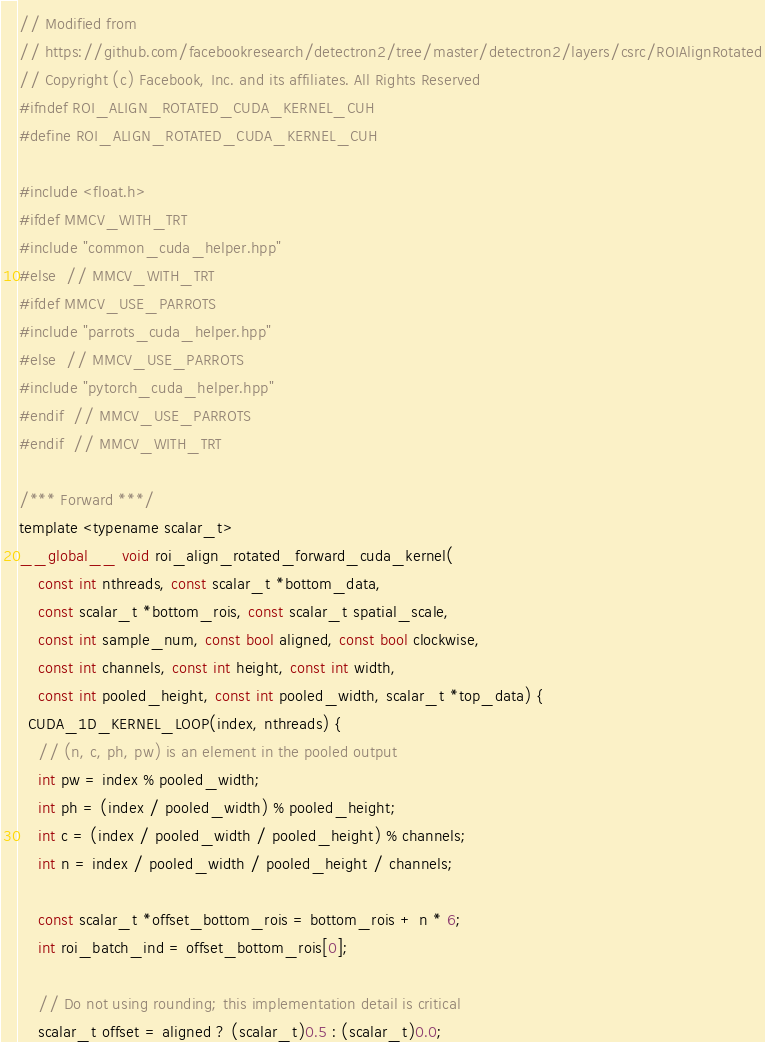Convert code to text. <code><loc_0><loc_0><loc_500><loc_500><_Cuda_>// Modified from
// https://github.com/facebookresearch/detectron2/tree/master/detectron2/layers/csrc/ROIAlignRotated
// Copyright (c) Facebook, Inc. and its affiliates. All Rights Reserved
#ifndef ROI_ALIGN_ROTATED_CUDA_KERNEL_CUH
#define ROI_ALIGN_ROTATED_CUDA_KERNEL_CUH

#include <float.h>
#ifdef MMCV_WITH_TRT
#include "common_cuda_helper.hpp"
#else  // MMCV_WITH_TRT
#ifdef MMCV_USE_PARROTS
#include "parrots_cuda_helper.hpp"
#else  // MMCV_USE_PARROTS
#include "pytorch_cuda_helper.hpp"
#endif  // MMCV_USE_PARROTS
#endif  // MMCV_WITH_TRT

/*** Forward ***/
template <typename scalar_t>
__global__ void roi_align_rotated_forward_cuda_kernel(
    const int nthreads, const scalar_t *bottom_data,
    const scalar_t *bottom_rois, const scalar_t spatial_scale,
    const int sample_num, const bool aligned, const bool clockwise,
    const int channels, const int height, const int width,
    const int pooled_height, const int pooled_width, scalar_t *top_data) {
  CUDA_1D_KERNEL_LOOP(index, nthreads) {
    // (n, c, ph, pw) is an element in the pooled output
    int pw = index % pooled_width;
    int ph = (index / pooled_width) % pooled_height;
    int c = (index / pooled_width / pooled_height) % channels;
    int n = index / pooled_width / pooled_height / channels;

    const scalar_t *offset_bottom_rois = bottom_rois + n * 6;
    int roi_batch_ind = offset_bottom_rois[0];

    // Do not using rounding; this implementation detail is critical
    scalar_t offset = aligned ? (scalar_t)0.5 : (scalar_t)0.0;</code> 